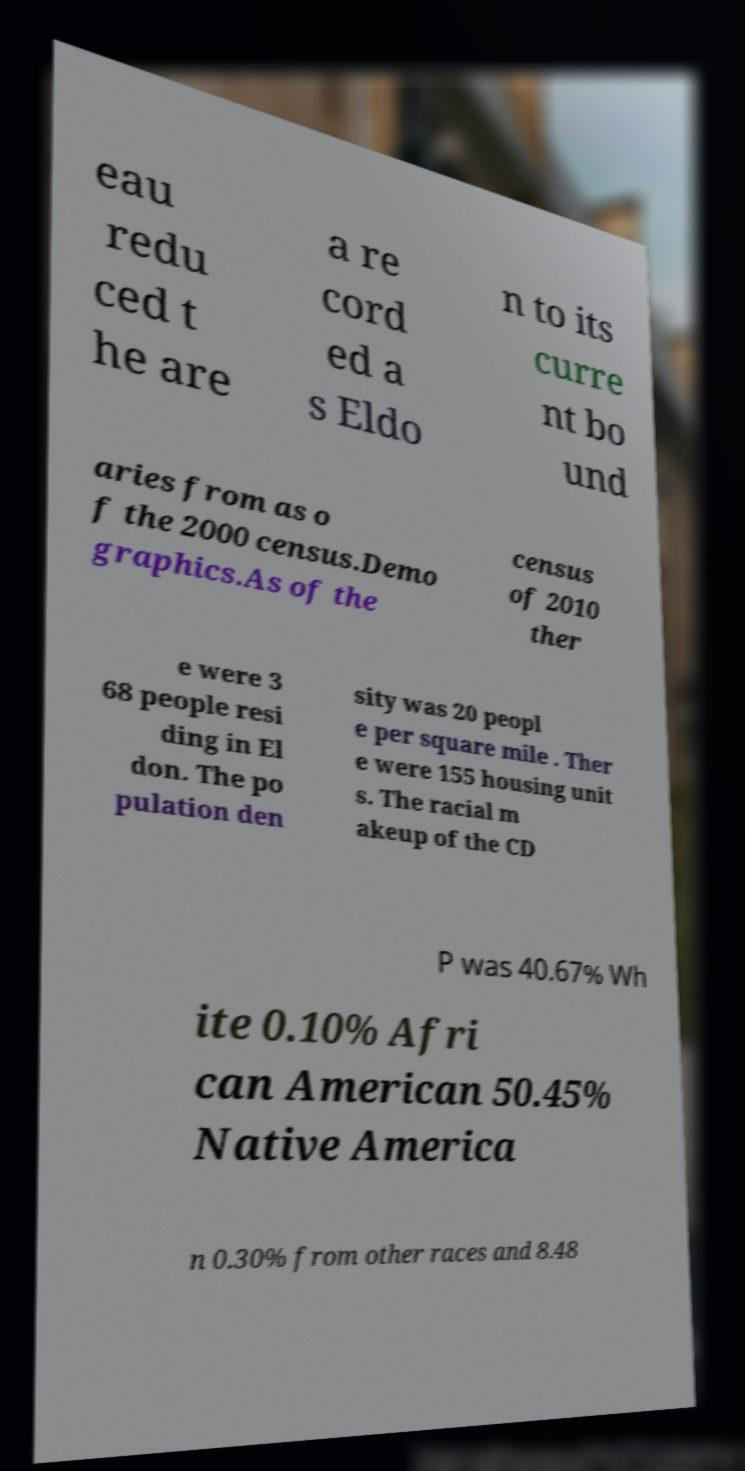Can you read and provide the text displayed in the image?This photo seems to have some interesting text. Can you extract and type it out for me? eau redu ced t he are a re cord ed a s Eldo n to its curre nt bo und aries from as o f the 2000 census.Demo graphics.As of the census of 2010 ther e were 3 68 people resi ding in El don. The po pulation den sity was 20 peopl e per square mile . Ther e were 155 housing unit s. The racial m akeup of the CD P was 40.67% Wh ite 0.10% Afri can American 50.45% Native America n 0.30% from other races and 8.48 